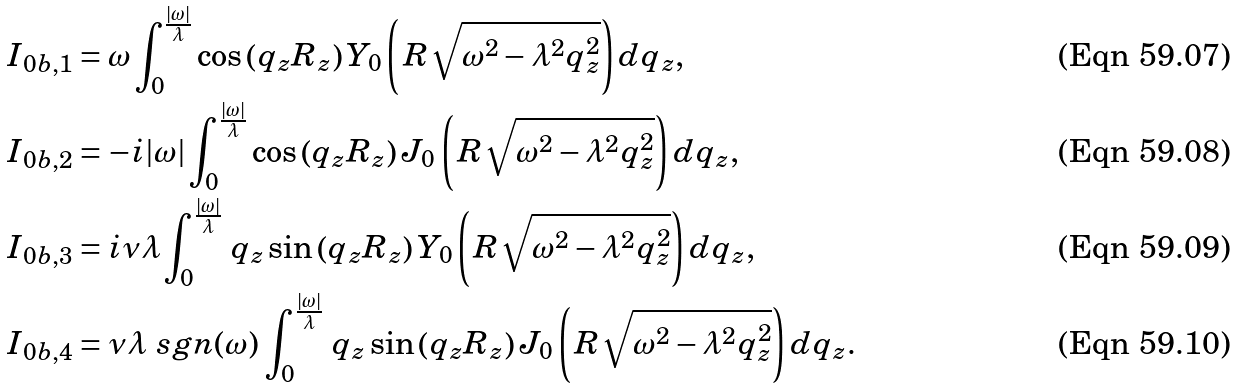<formula> <loc_0><loc_0><loc_500><loc_500>I _ { 0 b , 1 } & = \omega \int _ { 0 } ^ { \frac { | \omega | } { \lambda } } \cos \left ( q _ { z } R _ { z } \right ) Y _ { 0 } \left ( \, R \sqrt { \omega ^ { 2 } - \lambda ^ { 2 } q _ { z } ^ { 2 } } \right ) d q _ { z } , \\ I _ { 0 b , 2 } & = - i | \omega | \int _ { 0 } ^ { \frac { | \omega | } { \lambda } } \cos \left ( q _ { z } R _ { z } \right ) J _ { 0 } \left ( \, R \sqrt { \omega ^ { 2 } - \lambda ^ { 2 } q _ { z } ^ { 2 } } \right ) d q _ { z } , \\ I _ { 0 b , 3 } & = i \nu \lambda \int _ { 0 } ^ { \frac { | \omega | } { \lambda } } \, q _ { z } \sin \left ( q _ { z } R _ { z } \right ) Y _ { 0 } \left ( \, R \sqrt { \omega ^ { 2 } - \lambda ^ { 2 } q _ { z } ^ { 2 } } \right ) d q _ { z } , \\ I _ { 0 b , 4 } & = \nu \lambda \ s g n ( \omega ) \, \int _ { 0 } ^ { \frac { | \omega | } { \lambda } } \, q _ { z } \sin \left ( q _ { z } R _ { z } \right ) J _ { 0 } \left ( \, R \sqrt { \omega ^ { 2 } - \lambda ^ { 2 } q _ { z } ^ { 2 } } \right ) d q _ { z } .</formula> 